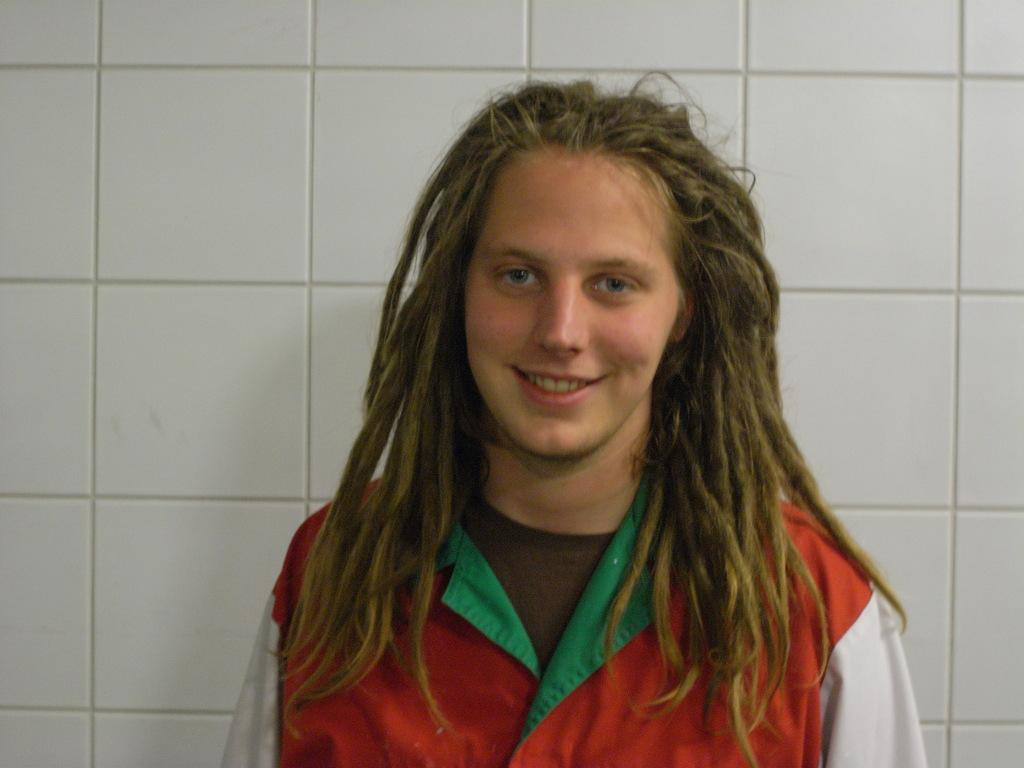What is the main subject of the image? There is a person standing in the middle of the image. What is the person doing in the image? The person is smiling. What can be seen in the background of the image? There is a wall in the background of the image. What type of rhythm can be heard coming from the person in the image? There is no indication of sound or rhythm in the image, as it only shows a person standing and smiling. 